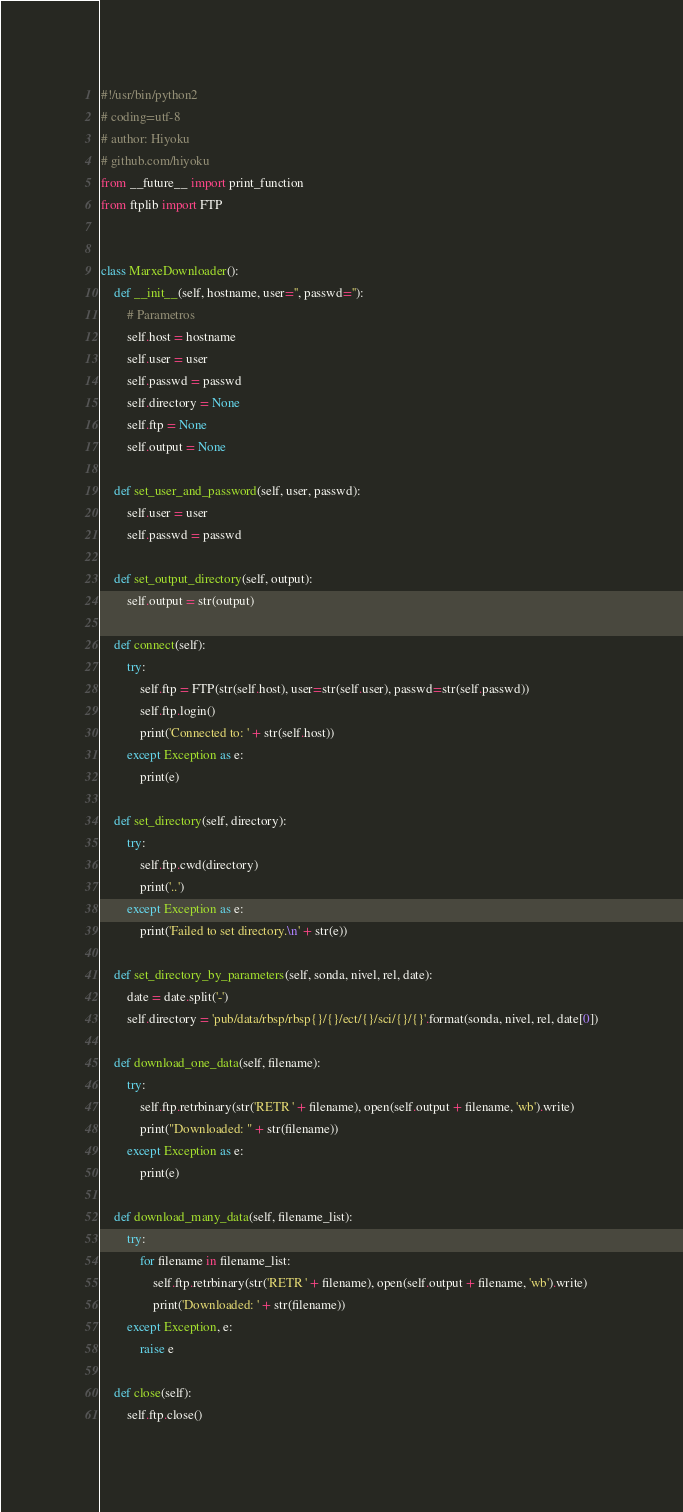Convert code to text. <code><loc_0><loc_0><loc_500><loc_500><_Python_>#!/usr/bin/python2
# coding=utf-8
# author: Hiyoku
# github.com/hiyoku
from __future__ import print_function
from ftplib import FTP


class MarxeDownloader():
    def __init__(self, hostname, user='', passwd=''):
        # Parametros
        self.host = hostname
        self.user = user
        self.passwd = passwd
        self.directory = None
        self.ftp = None
        self.output = None

    def set_user_and_password(self, user, passwd):
        self.user = user
        self.passwd = passwd

    def set_output_directory(self, output):
        self.output = str(output)

    def connect(self):
        try:
            self.ftp = FTP(str(self.host), user=str(self.user), passwd=str(self.passwd))
            self.ftp.login()
            print('Connected to: ' + str(self.host))
        except Exception as e:
            print(e)

    def set_directory(self, directory):
        try:
            self.ftp.cwd(directory)
            print('..')
        except Exception as e:
            print('Failed to set directory.\n' + str(e))

    def set_directory_by_parameters(self, sonda, nivel, rel, date):
        date = date.split('-')
        self.directory = 'pub/data/rbsp/rbsp{}/{}/ect/{}/sci/{}/{}'.format(sonda, nivel, rel, date[0])

    def download_one_data(self, filename):
        try:
            self.ftp.retrbinary(str('RETR ' + filename), open(self.output + filename, 'wb').write)
            print("Downloaded: " + str(filename))
        except Exception as e:
            print(e)

    def download_many_data(self, filename_list):
        try:
            for filename in filename_list:
                self.ftp.retrbinary(str('RETR ' + filename), open(self.output + filename, 'wb').write)
                print('Downloaded: ' + str(filename))
        except Exception, e:
            raise e

    def close(self):
        self.ftp.close()
</code> 